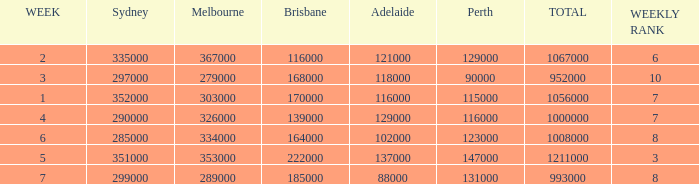What is the highest number of Brisbane viewers? 222000.0. 